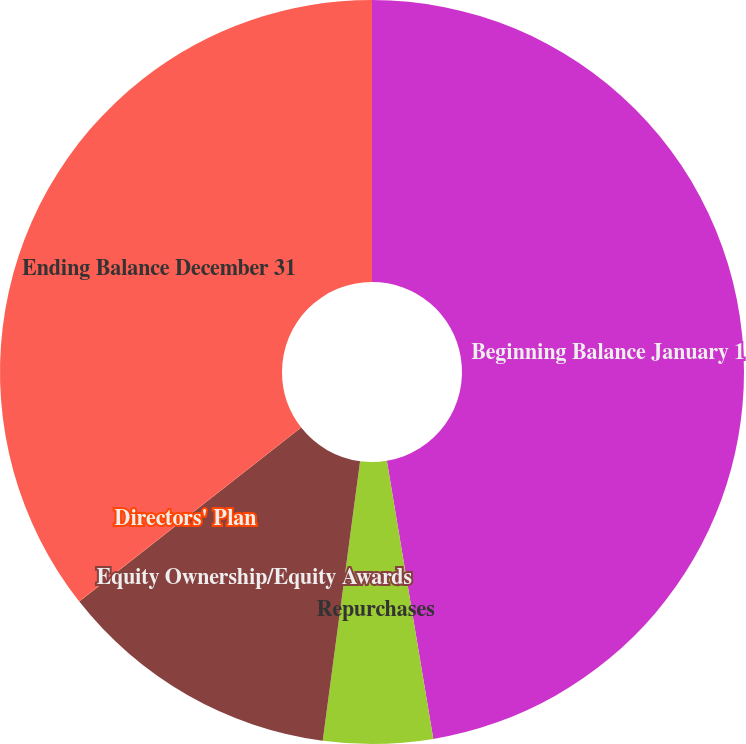Convert chart. <chart><loc_0><loc_0><loc_500><loc_500><pie_chart><fcel>Beginning Balance January 1<fcel>Repurchases<fcel>Equity Ownership/Equity Awards<fcel>Directors' Plan<fcel>Ending Balance December 31<nl><fcel>47.37%<fcel>4.75%<fcel>12.3%<fcel>0.02%<fcel>35.57%<nl></chart> 